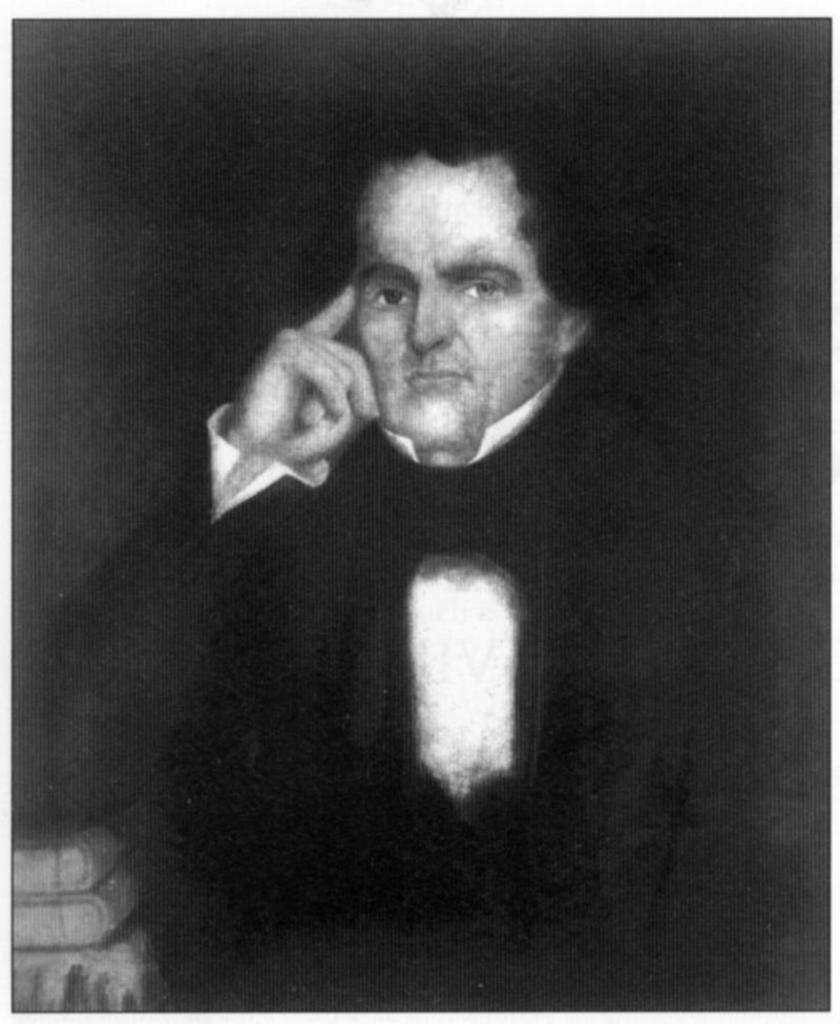What is the main subject of the image? There is a depiction of a man in the image. What else can be seen in the image besides the man? There are depictions of books in the image. What is the color scheme of the image? The image is black and white in color. Are there any plants visible in the image? There are no plants visible in the image; it only depicts a man and books. 